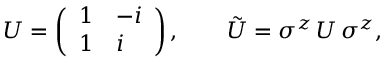<formula> <loc_0><loc_0><loc_500><loc_500>U = \left ( \begin{array} { l l } { 1 } & { - i } \\ { 1 } & { i } \end{array} \right ) , \quad \tilde { U } = \sigma ^ { z } \, U \, \sigma ^ { z } ,</formula> 